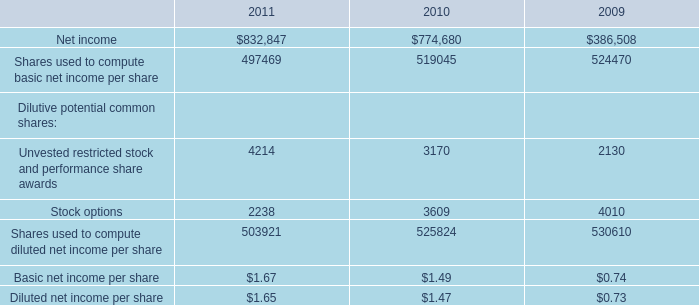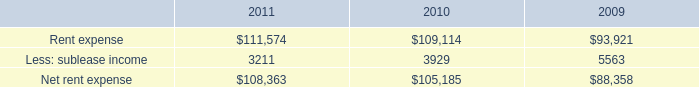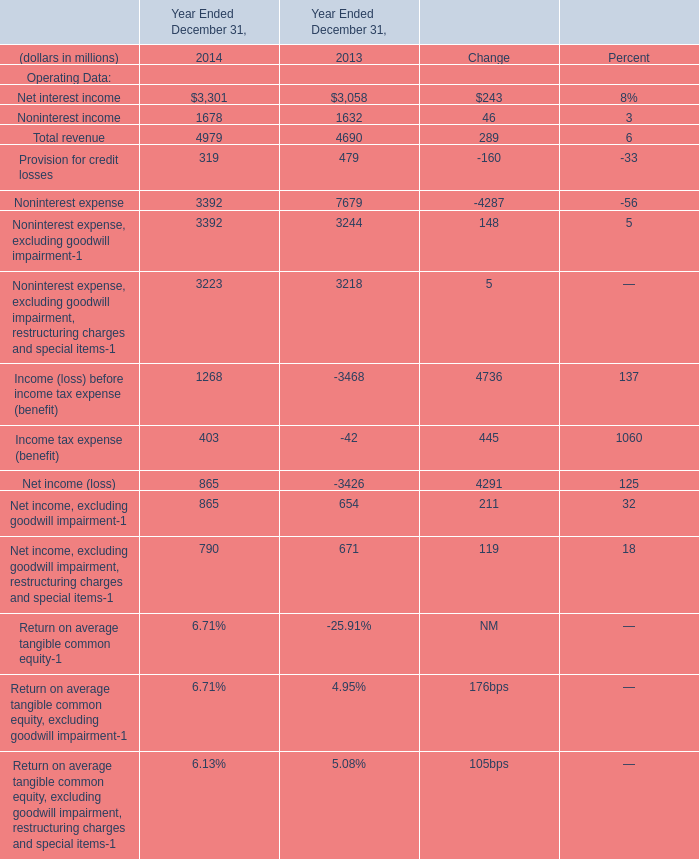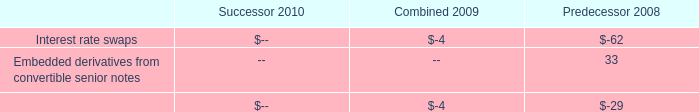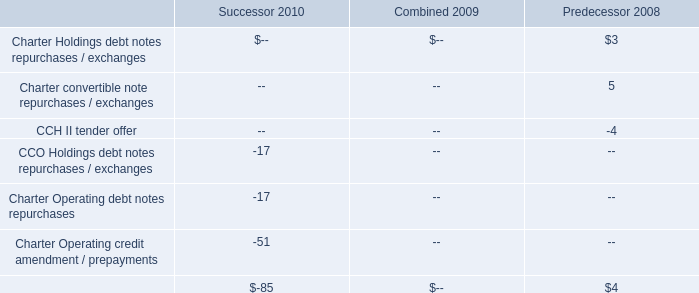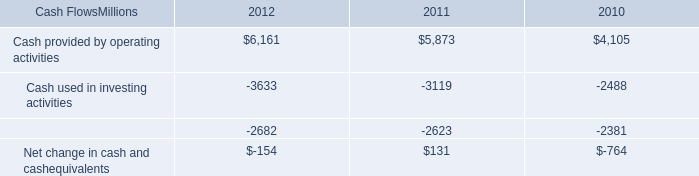what would 2012 capital expenditures have been without the early buyout of locomotives , in millions? 
Computations: (3633 - 75)
Answer: 3558.0. 